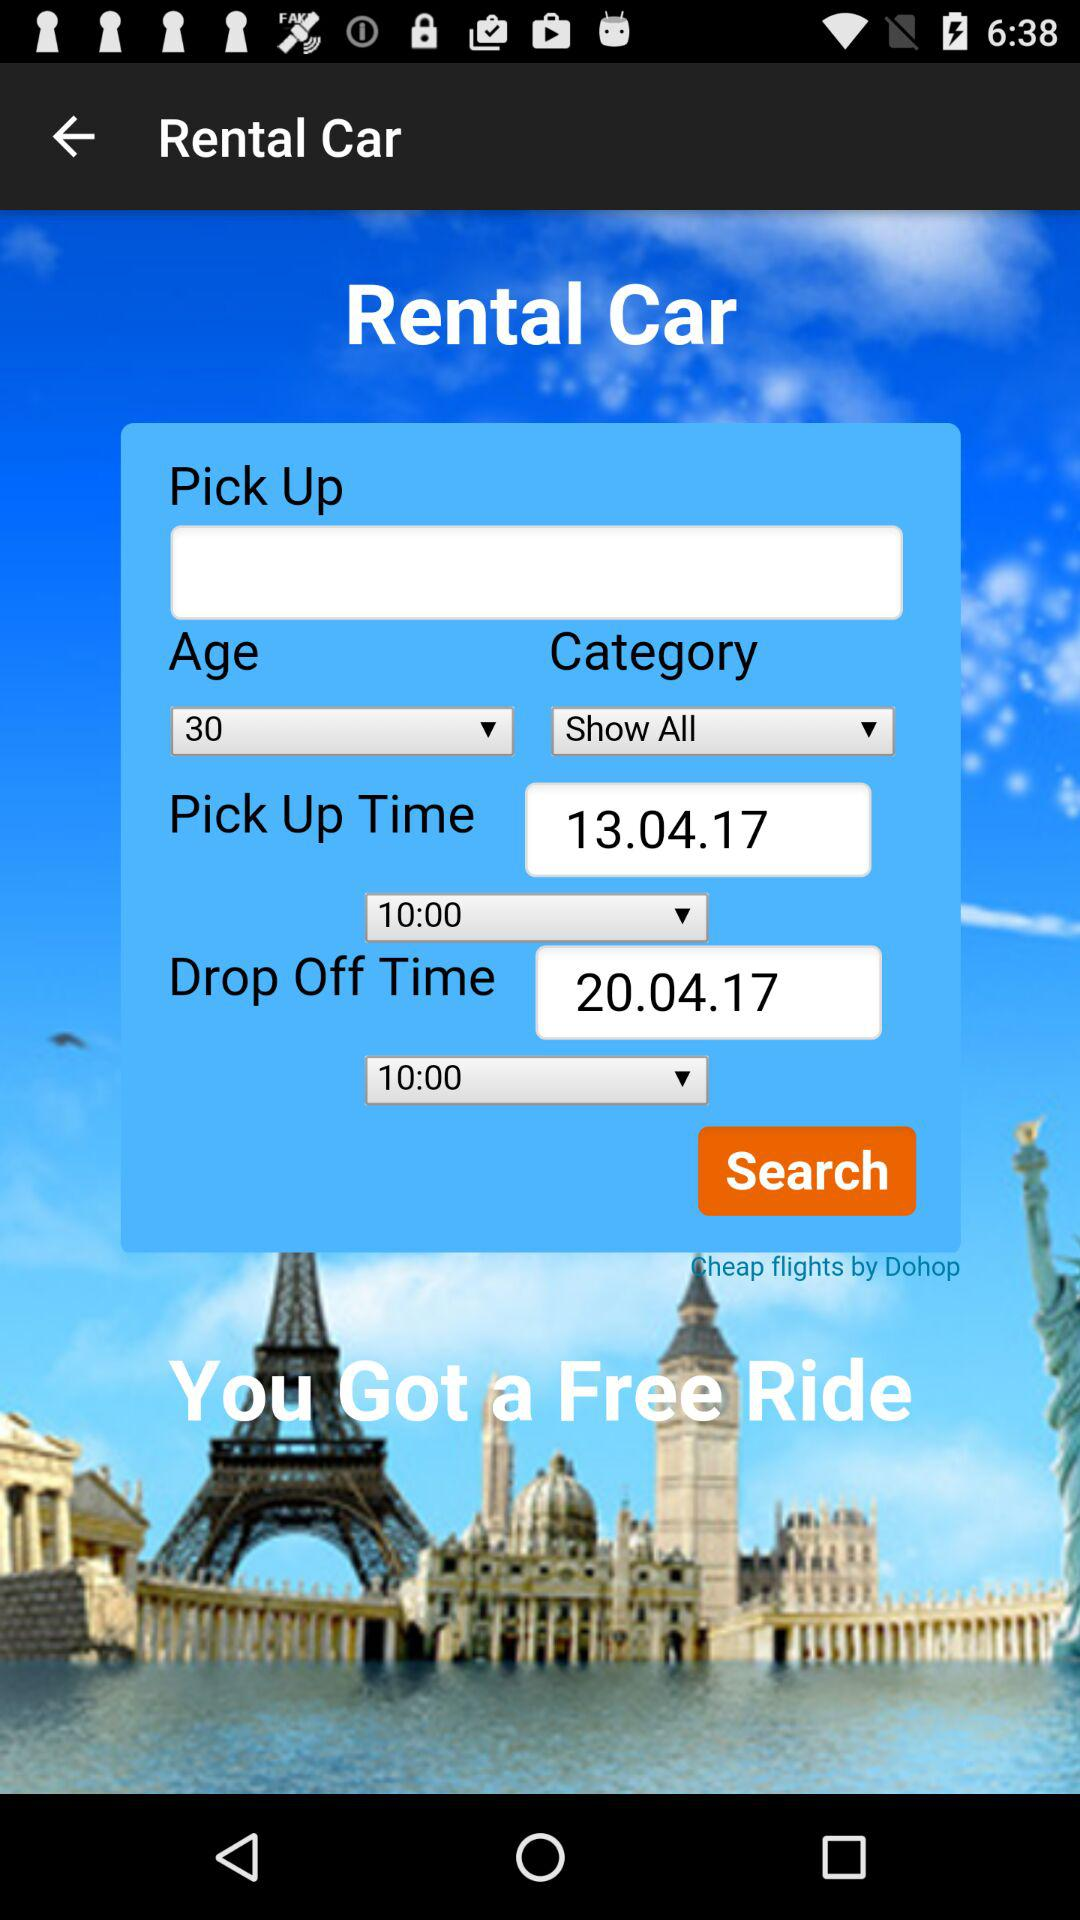What is the name of the application? The name of the application is "Rental Car". 